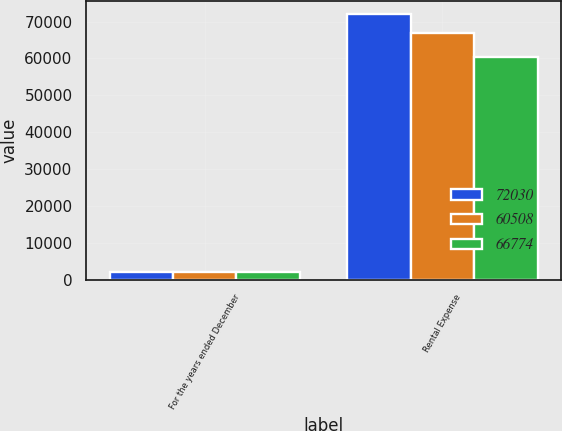Convert chart. <chart><loc_0><loc_0><loc_500><loc_500><stacked_bar_chart><ecel><fcel>For the years ended December<fcel>Rental Expense<nl><fcel>72030<fcel>2017<fcel>72030<nl><fcel>60508<fcel>2016<fcel>66774<nl><fcel>66774<fcel>2015<fcel>60508<nl></chart> 